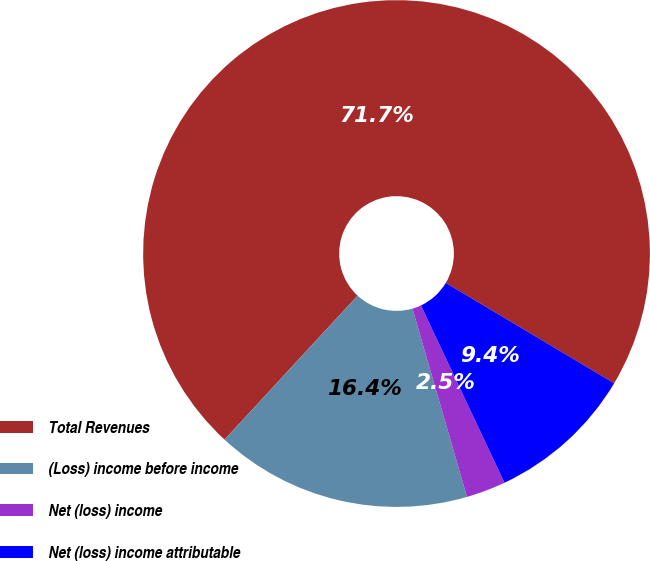Convert chart. <chart><loc_0><loc_0><loc_500><loc_500><pie_chart><fcel>Total Revenues<fcel>(Loss) income before income<fcel>Net (loss) income<fcel>Net (loss) income attributable<nl><fcel>71.68%<fcel>16.36%<fcel>2.52%<fcel>9.44%<nl></chart> 